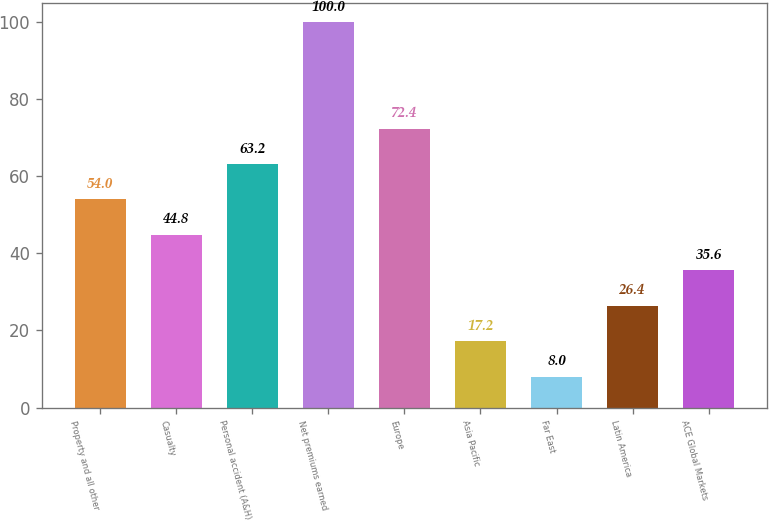Convert chart. <chart><loc_0><loc_0><loc_500><loc_500><bar_chart><fcel>Property and all other<fcel>Casualty<fcel>Personal accident (A&H)<fcel>Net premiums earned<fcel>Europe<fcel>Asia Pacific<fcel>Far East<fcel>Latin America<fcel>ACE Global Markets<nl><fcel>54<fcel>44.8<fcel>63.2<fcel>100<fcel>72.4<fcel>17.2<fcel>8<fcel>26.4<fcel>35.6<nl></chart> 